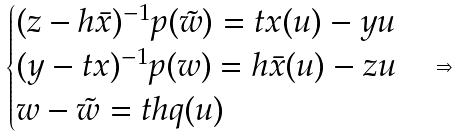<formula> <loc_0><loc_0><loc_500><loc_500>\begin{cases} ( z - h \bar { x } ) ^ { - 1 } p ( \tilde { w } ) = t x ( u ) - y u \\ ( y - t x ) ^ { - 1 } p ( w ) = h \bar { x } ( u ) - z u \\ w - \tilde { w } = t h q ( u ) \end{cases} \Rightarrow</formula> 